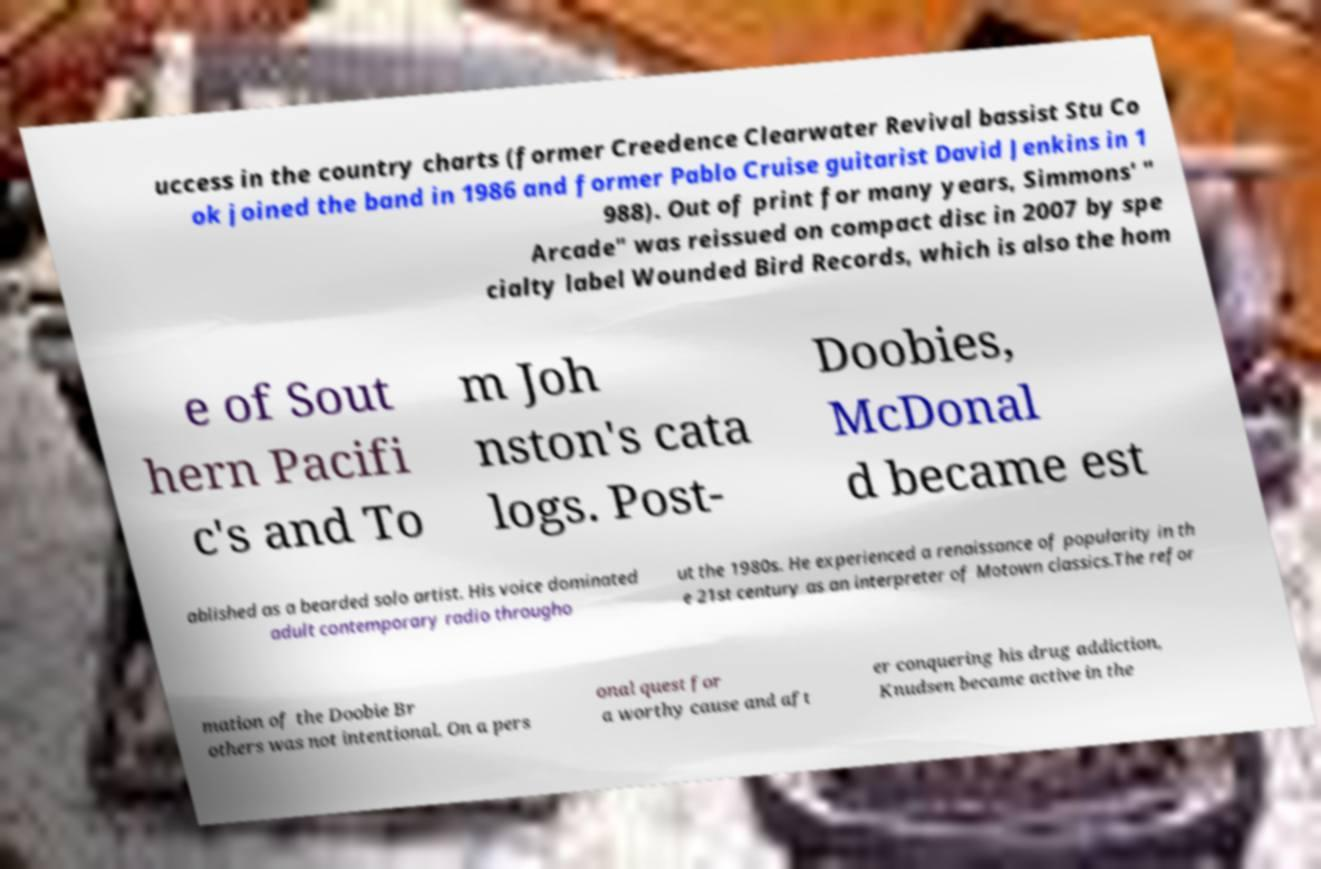Could you assist in decoding the text presented in this image and type it out clearly? uccess in the country charts (former Creedence Clearwater Revival bassist Stu Co ok joined the band in 1986 and former Pablo Cruise guitarist David Jenkins in 1 988). Out of print for many years, Simmons' " Arcade" was reissued on compact disc in 2007 by spe cialty label Wounded Bird Records, which is also the hom e of Sout hern Pacifi c's and To m Joh nston's cata logs. Post- Doobies, McDonal d became est ablished as a bearded solo artist. His voice dominated adult contemporary radio througho ut the 1980s. He experienced a renaissance of popularity in th e 21st century as an interpreter of Motown classics.The refor mation of the Doobie Br others was not intentional. On a pers onal quest for a worthy cause and aft er conquering his drug addiction, Knudsen became active in the 